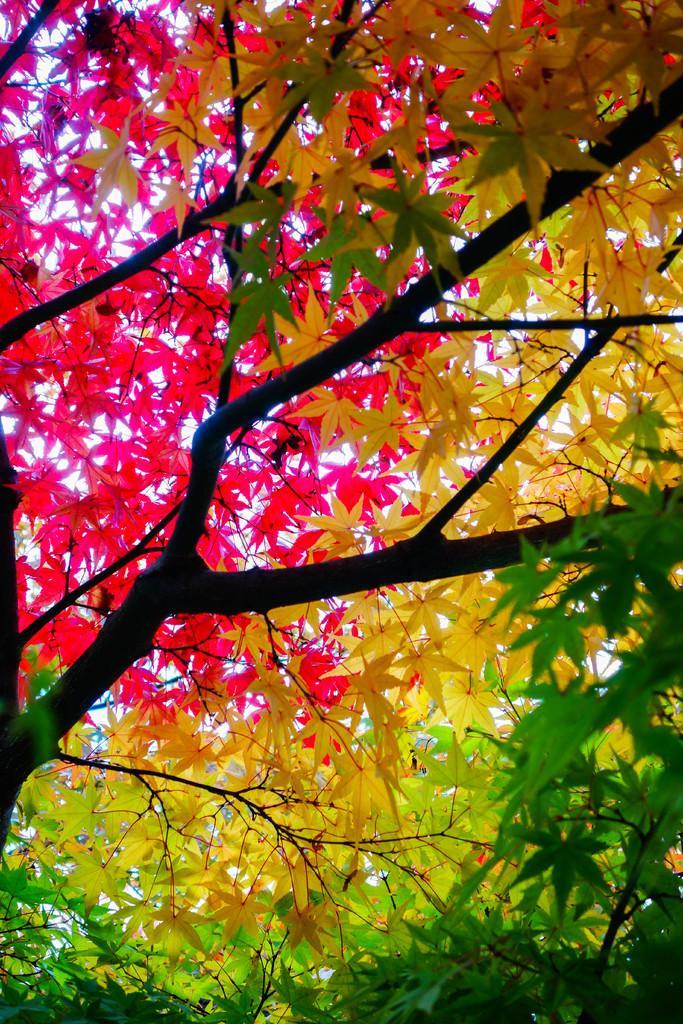Could you give a brief overview of what you see in this image? This image consists of trees. And we can see the leaves in different colors. In the front, there are green, yellow, and pink leaves. 